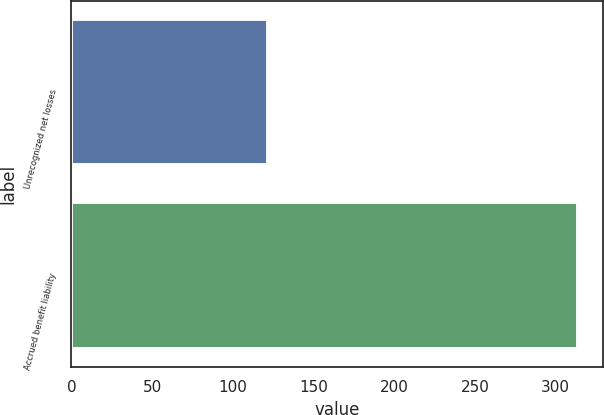Convert chart to OTSL. <chart><loc_0><loc_0><loc_500><loc_500><bar_chart><fcel>Unrecognized net losses<fcel>Accrued benefit liability<nl><fcel>122<fcel>314<nl></chart> 